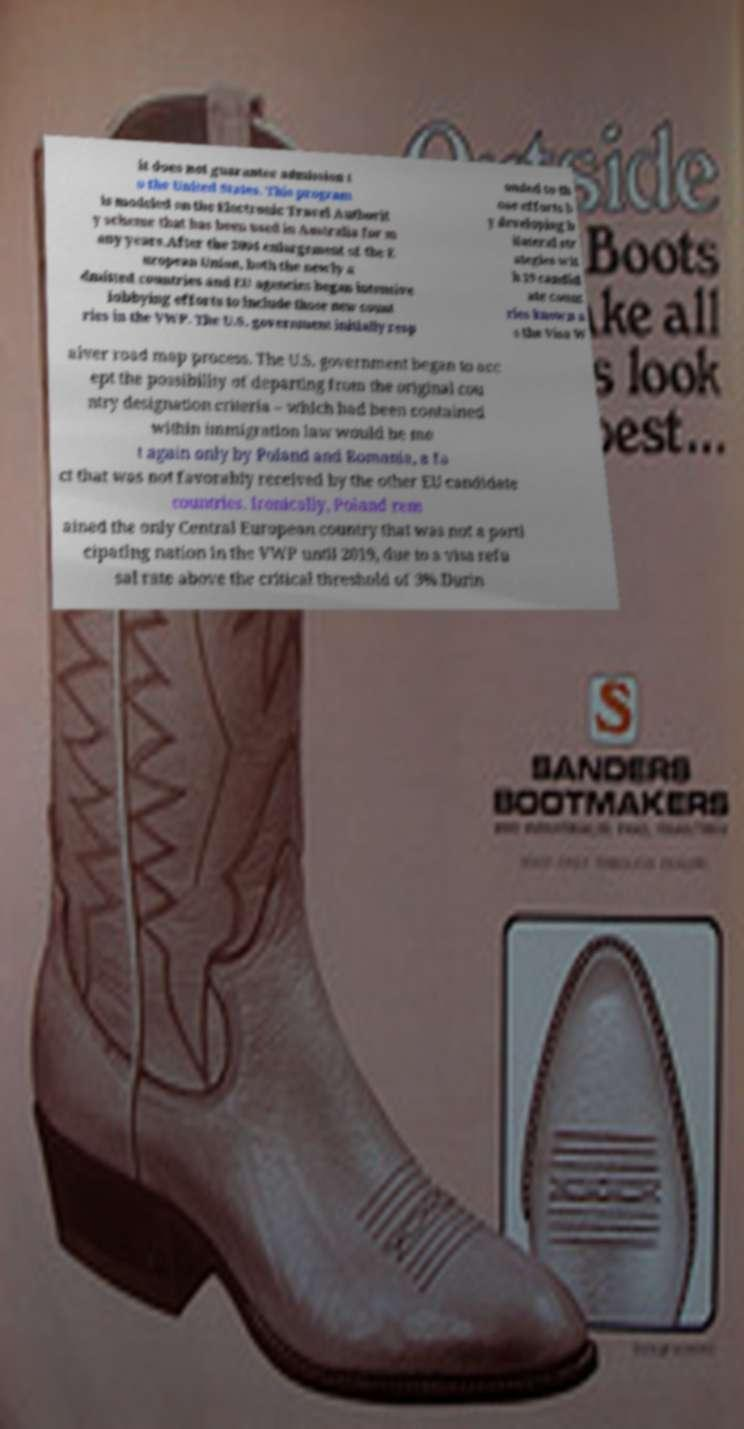What messages or text are displayed in this image? I need them in a readable, typed format. it does not guarantee admission t o the United States. This program is modeled on the Electronic Travel Authorit y scheme that has been used in Australia for m any years.After the 2004 enlargement of the E uropean Union, both the newly a dmitted countries and EU agencies began intensive lobbying efforts to include those new count ries in the VWP. The U.S. government initially resp onded to th ose efforts b y developing b ilateral str ategies wit h 19 candid ate count ries known a s the Visa W aiver road map process. The U.S. government began to acc ept the possibility of departing from the original cou ntry designation criteria – which had been contained within immigration law would be me t again only by Poland and Romania, a fa ct that was not favorably received by the other EU candidate countries. Ironically, Poland rem ained the only Central European country that was not a parti cipating nation in the VWP until 2019, due to a visa refu sal rate above the critical threshold of 3%.Durin 